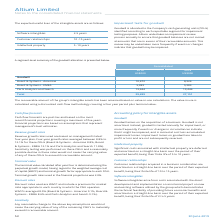From Altium Limited's financial document, What are the segments of Goodwill allocations in the table? The document contains multiple relevant values: Board & Systems - Americas, Board & Systems - EMEA, Parts Analytics and Search. From the document: "Parts Analytics and Search 13,444 13,444 Board & Systems - EMEA 5,383 5,383 Board & Systems - Americas 10,672 8,324..." Also, What were the terminal growth rates used in the financial projections? According to the financial document, 2.0%. The relevant text states: "growth rates used in the financial projections was 2.0%...." Also, What is the finite life of intellectual property? According to the financial document, 5 to 10 years. The relevant text states: "expected benefit, being their finite life of 5 to 10 years...." Additionally, Which segment of total goodwill was the largest in 2019? Parts Analytics and Search. The document states: "Parts Analytics and Search 13,444 13,444..." Also, How many segments in 2019 had a goodwill value of above 5,000 thousand? Counting the relevant items in the document:  Board & Systems - Americas ,  Board & Systems - EMEA ,  Parts Analytics and Search , I find 3 instances. The key data points involved are: Board & Systems - Americas, Board & Systems - EMEA, Parts Analytics and Search. Also, can you calculate: What is the percentage increase in the total goodwill allocation from 2018 to 2019? To answer this question, I need to perform calculations using the financial data. The calculation is: (29,499-27,151)/27,151, which equals 8.65 (percentage). This is based on the information: "Total 29,499 27,151 Total 29,499 27,151..." The key data points involved are: 27,151, 29,499. 